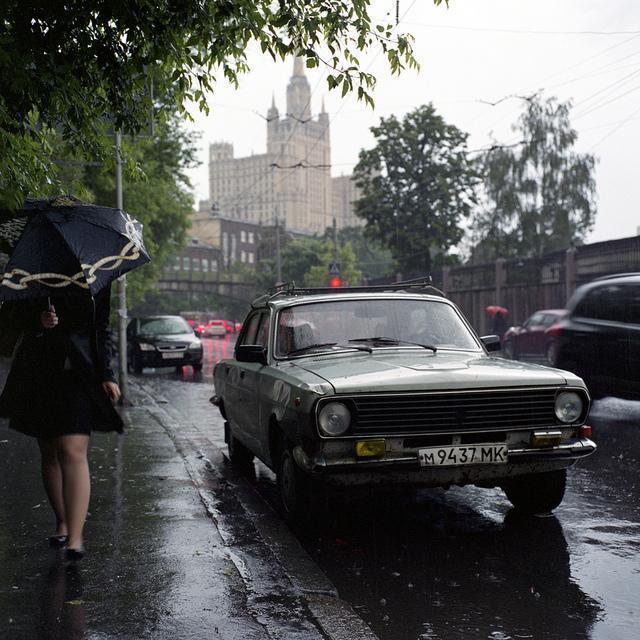How many cars are in the picture?
Give a very brief answer. 3. 